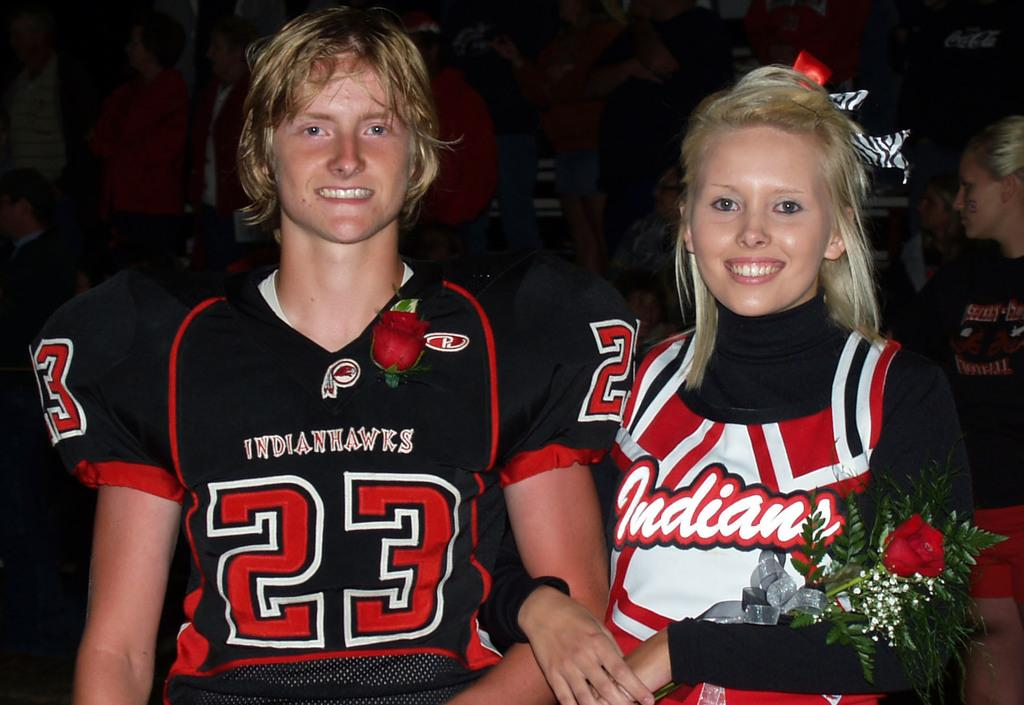<image>
Create a compact narrative representing the image presented. An Indians cheerleader holds a rose next to number 23 of the football team. 